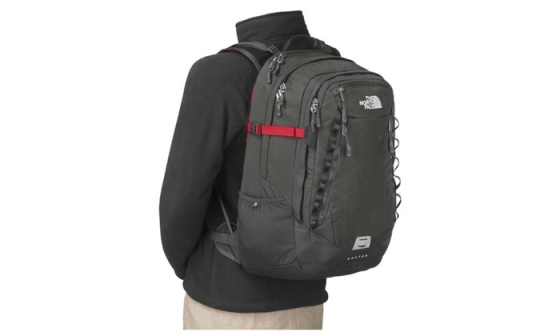What might be some realistic day-to-day scenarios where this backpack excels? One realistic day-to-day scenario where this backpack excels is for a commuter. Picture someone navigating a bustling city, hopping on and off public transit. The ergonomic design and balanced weight distribution make it comfortable to carry even with a load of work essentials, a laptop, and lunch. The multiple compartments keep everything organized, and the side pockets provide easy access to a water bottle or umbrella. The durable material withstands the wear and tear of daily use, ensuring reliability and longevity. How about during a casual day out? During a casual day out, this backpack is equally advantageous. Whether you’re exploring a new city, going for a picnic, or just spending the day at a park, the backpack offers ample space for all your necessities. It can hold snacks, a blanket, a camera, and even some leisure items like a book or a frisbee. The sleek design and stylish look keep you fashionable while the functional compartments ensure that you’re prepared for any spontaneous adventure that comes your way. 